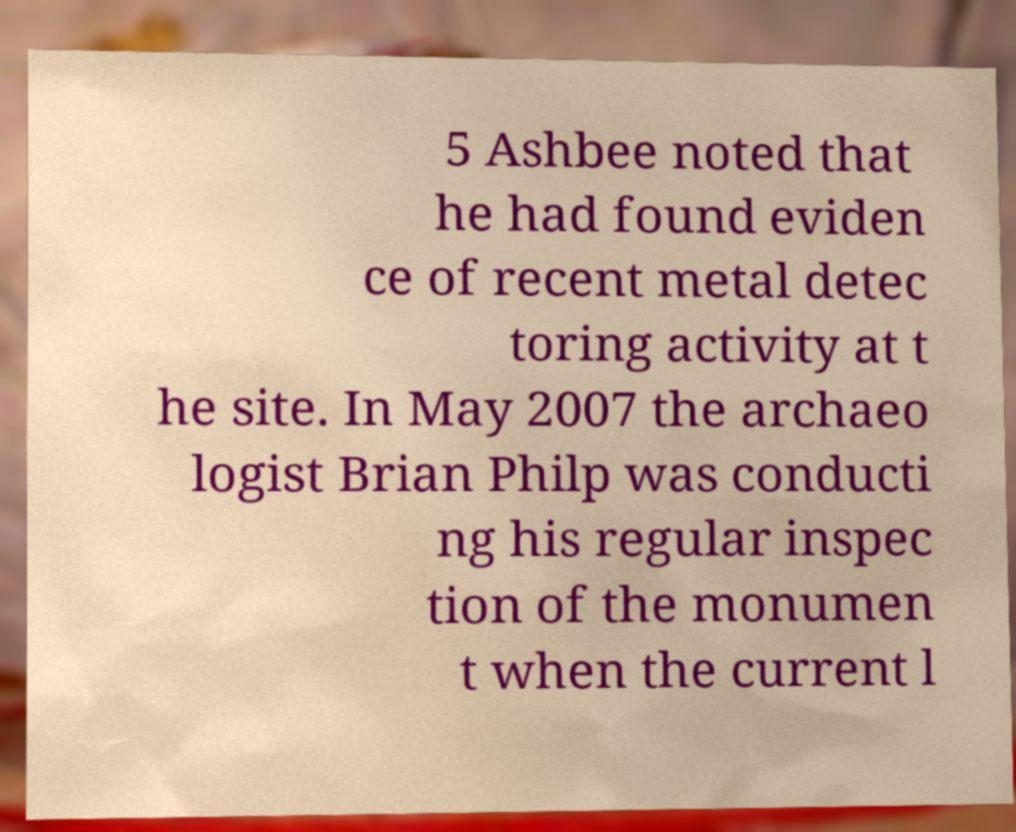What messages or text are displayed in this image? I need them in a readable, typed format. 5 Ashbee noted that he had found eviden ce of recent metal detec toring activity at t he site. In May 2007 the archaeo logist Brian Philp was conducti ng his regular inspec tion of the monumen t when the current l 